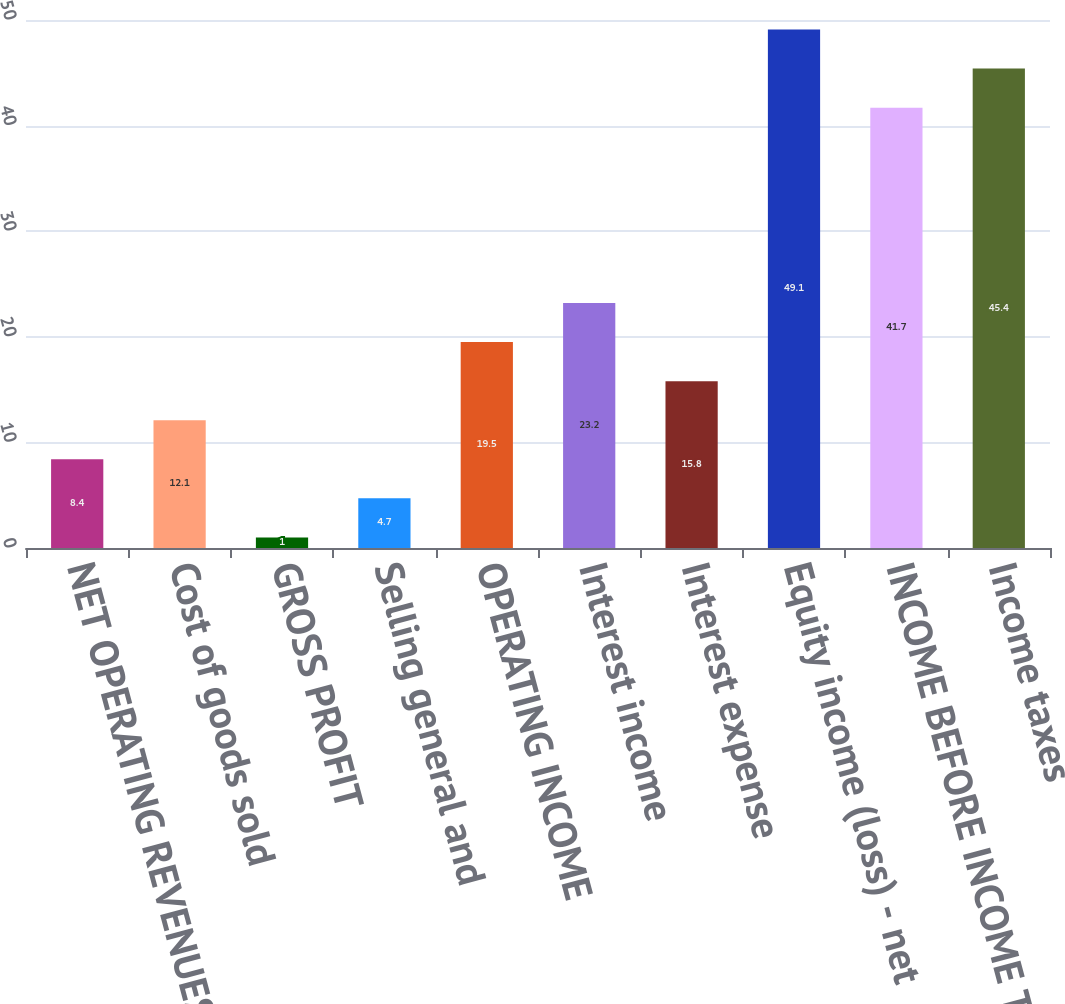<chart> <loc_0><loc_0><loc_500><loc_500><bar_chart><fcel>NET OPERATING REVENUES<fcel>Cost of goods sold<fcel>GROSS PROFIT<fcel>Selling general and<fcel>OPERATING INCOME<fcel>Interest income<fcel>Interest expense<fcel>Equity income (loss) - net<fcel>INCOME BEFORE INCOME TAXES<fcel>Income taxes<nl><fcel>8.4<fcel>12.1<fcel>1<fcel>4.7<fcel>19.5<fcel>23.2<fcel>15.8<fcel>49.1<fcel>41.7<fcel>45.4<nl></chart> 